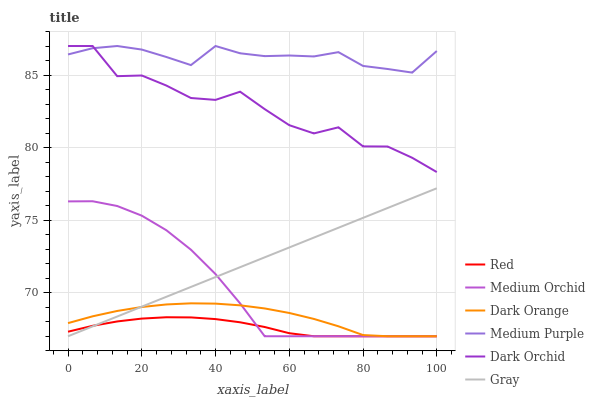Does Red have the minimum area under the curve?
Answer yes or no. Yes. Does Medium Purple have the maximum area under the curve?
Answer yes or no. Yes. Does Gray have the minimum area under the curve?
Answer yes or no. No. Does Gray have the maximum area under the curve?
Answer yes or no. No. Is Gray the smoothest?
Answer yes or no. Yes. Is Dark Orchid the roughest?
Answer yes or no. Yes. Is Medium Orchid the smoothest?
Answer yes or no. No. Is Medium Orchid the roughest?
Answer yes or no. No. Does Dark Orange have the lowest value?
Answer yes or no. Yes. Does Dark Orchid have the lowest value?
Answer yes or no. No. Does Medium Purple have the highest value?
Answer yes or no. Yes. Does Gray have the highest value?
Answer yes or no. No. Is Dark Orange less than Dark Orchid?
Answer yes or no. Yes. Is Medium Purple greater than Red?
Answer yes or no. Yes. Does Medium Orchid intersect Dark Orange?
Answer yes or no. Yes. Is Medium Orchid less than Dark Orange?
Answer yes or no. No. Is Medium Orchid greater than Dark Orange?
Answer yes or no. No. Does Dark Orange intersect Dark Orchid?
Answer yes or no. No. 